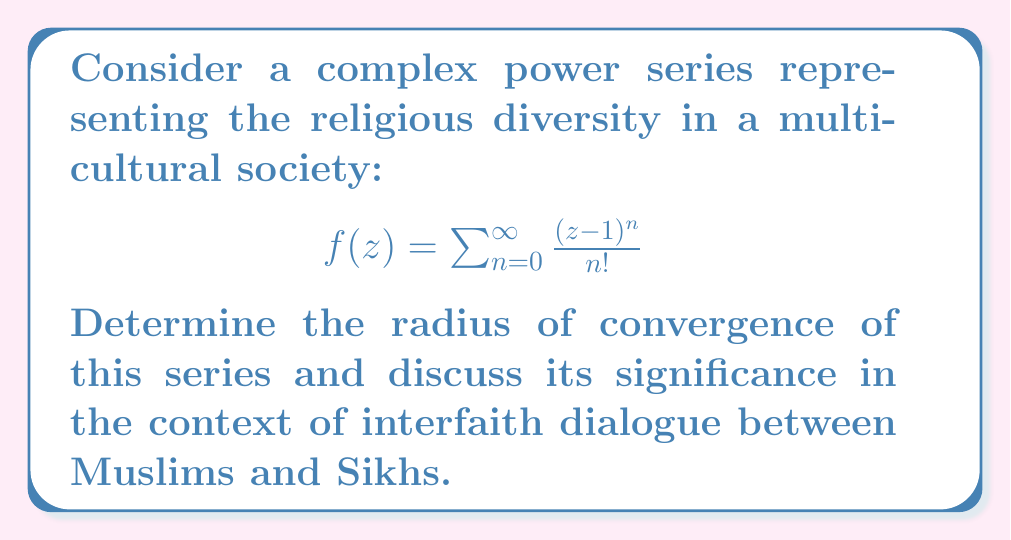Show me your answer to this math problem. To analyze the convergence of this complex power series, we'll follow these steps:

1) First, we recognize this series as the Taylor series expansion of $e^{(z-1)}$ centered at $z=1$.

2) For a power series $\sum_{n=0}^{\infty} a_n(z-z_0)^n$, the radius of convergence R is given by:

   $$R = \frac{1}{\limsup_{n\to\infty} \sqrt[n]{|a_n|}}$$

3) In our case, $a_n = \frac{1}{n!}$, so we need to evaluate:

   $$R = \frac{1}{\limsup_{n\to\infty} \sqrt[n]{\frac{1}{n!}}}$$

4) Using Stirling's approximation for large n:

   $$n! \approx \sqrt{2\pi n}\left(\frac{n}{e}\right)^n$$

5) Substituting this into our limit:

   $$\limsup_{n\to\infty} \sqrt[n]{\frac{1}{n!}} \approx \limsup_{n\to\infty} \frac{e}{n} = 0$$

6) Therefore, $R = \frac{1}{0} = \infty$

This means the series converges for all complex numbers z.

In the context of interfaith dialogue, this infinite radius of convergence can be interpreted as representing the unlimited potential for understanding and cooperation between different faiths, such as Islam and Sikhism. Just as the series can represent any complex number, interfaith dialogue can encompass a wide range of beliefs and perspectives.

The center point $z=1$ could symbolize a common ground or shared values between faiths, while the expansion in all directions represents the diverse ways these faiths can interact and find common understanding.
Answer: The radius of convergence is infinity (R = $\infty$), meaning the series converges for all complex numbers z. This represents the unlimited potential for interfaith understanding and cooperation. 